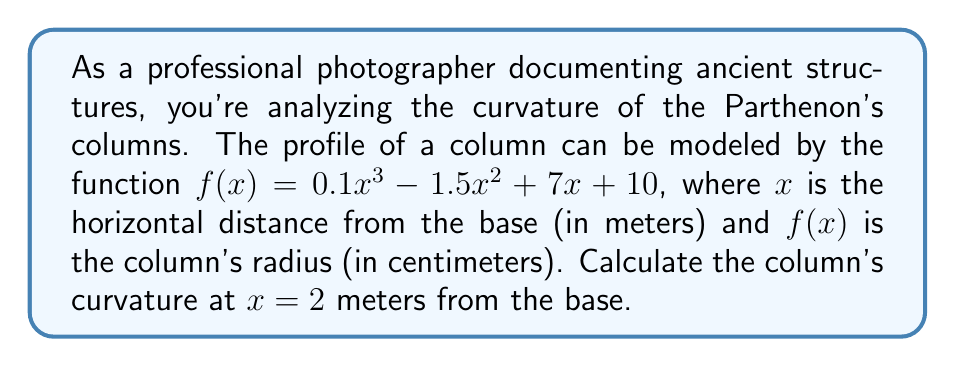Give your solution to this math problem. To find the curvature of the column at a specific point, we need to use the curvature formula:

$$\kappa = \frac{|f''(x)|}{(1 + (f'(x))^2)^{3/2}}$$

Let's solve this step by step:

1. Find $f'(x)$:
   $$f'(x) = 0.3x^2 - 3x + 7$$

2. Find $f''(x)$:
   $$f''(x) = 0.6x - 3$$

3. Calculate $f'(2)$:
   $$f'(2) = 0.3(2)^2 - 3(2) + 7 = 1.2 - 6 + 7 = 2.2$$

4. Calculate $f''(2)$:
   $$f''(2) = 0.6(2) - 3 = 1.2 - 3 = -1.8$$

5. Apply the curvature formula:
   $$\kappa = \frac{|-1.8|}{(1 + (2.2)^2)^{3/2}}$$

6. Simplify:
   $$\kappa = \frac{1.8}{(1 + 4.84)^{3/2}} = \frac{1.8}{(5.84)^{3/2}} \approx 0.1283$$

The curvature at $x = 2$ meters from the base is approximately 0.1283 m^(-1).
Answer: 0.1283 m^(-1) 